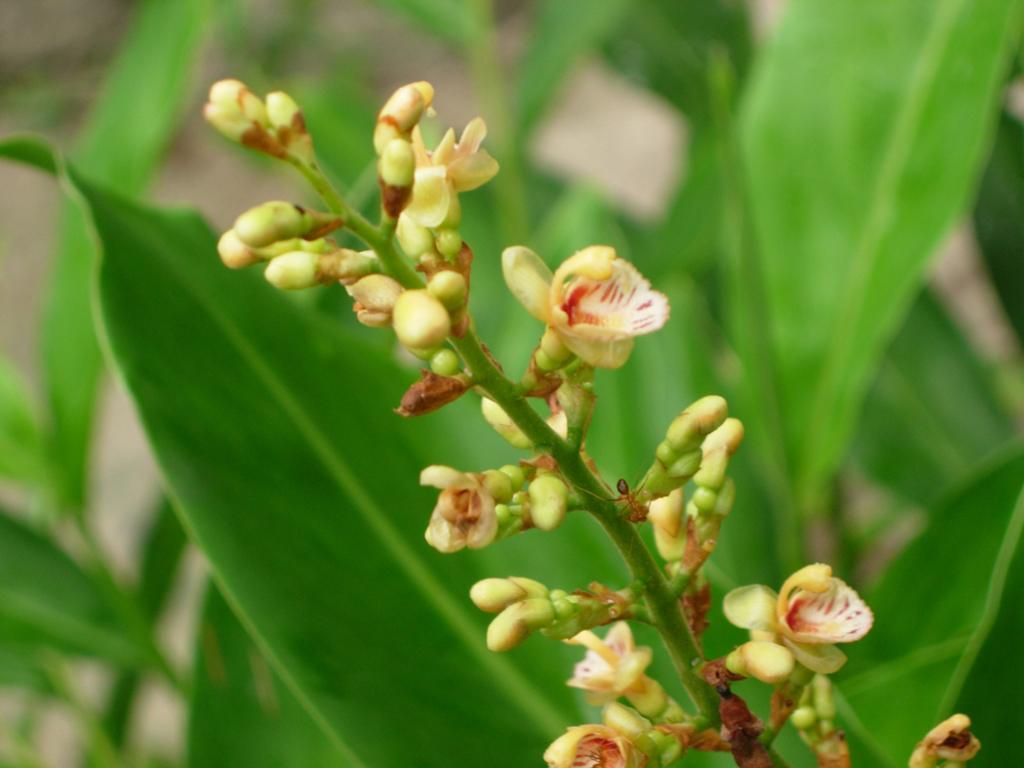In one or two sentences, can you explain what this image depicts? In this image we can see an insect on the plant. In the background we can see the leaves. 